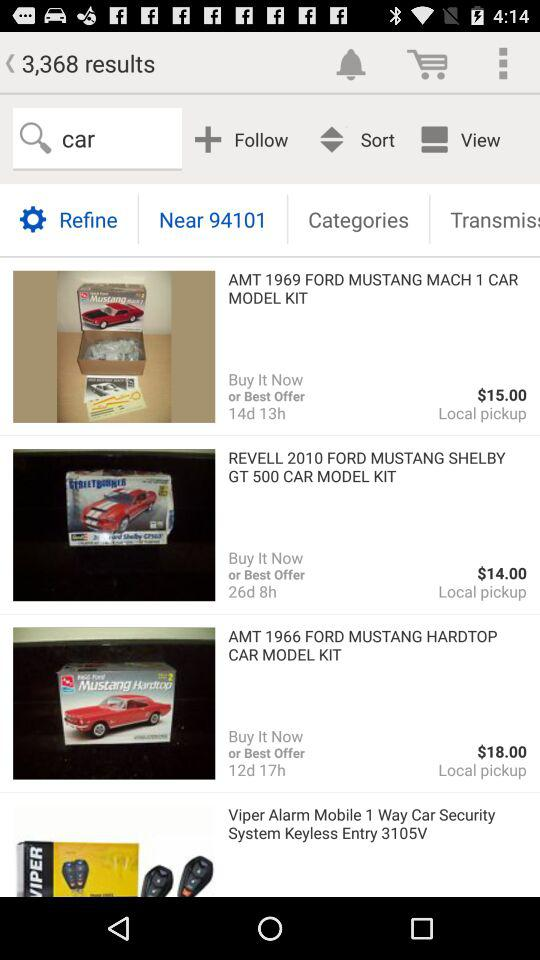How many of the items are available for local pickup?
Answer the question using a single word or phrase. 3 